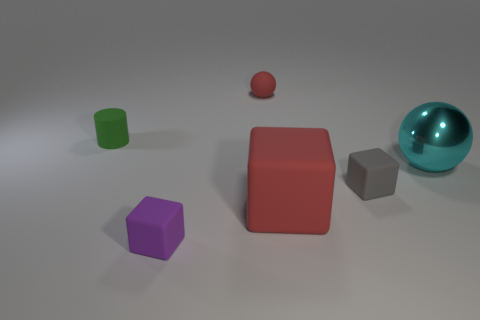There is a object that is the same color as the big cube; what is it made of?
Make the answer very short. Rubber. Does the small rubber ball have the same color as the large cube?
Provide a short and direct response. Yes. What is the shape of the tiny thing that is both in front of the green thing and left of the large red block?
Ensure brevity in your answer.  Cube. There is a red object that is in front of the rubber object that is to the left of the small purple block; is there a big metal object to the right of it?
Offer a terse response. Yes. What number of things are balls behind the big cyan shiny thing or balls on the left side of the tiny gray matte block?
Give a very brief answer. 1. Is the material of the red object in front of the cylinder the same as the green object?
Provide a short and direct response. Yes. The object that is behind the gray rubber object and in front of the cylinder is made of what material?
Provide a short and direct response. Metal. What is the color of the cube that is in front of the big thing in front of the small gray block?
Your answer should be very brief. Purple. There is a large thing that is the same shape as the tiny red thing; what is its material?
Offer a terse response. Metal. The small matte block behind the tiny rubber block that is to the left of the tiny block on the right side of the small red sphere is what color?
Give a very brief answer. Gray. 